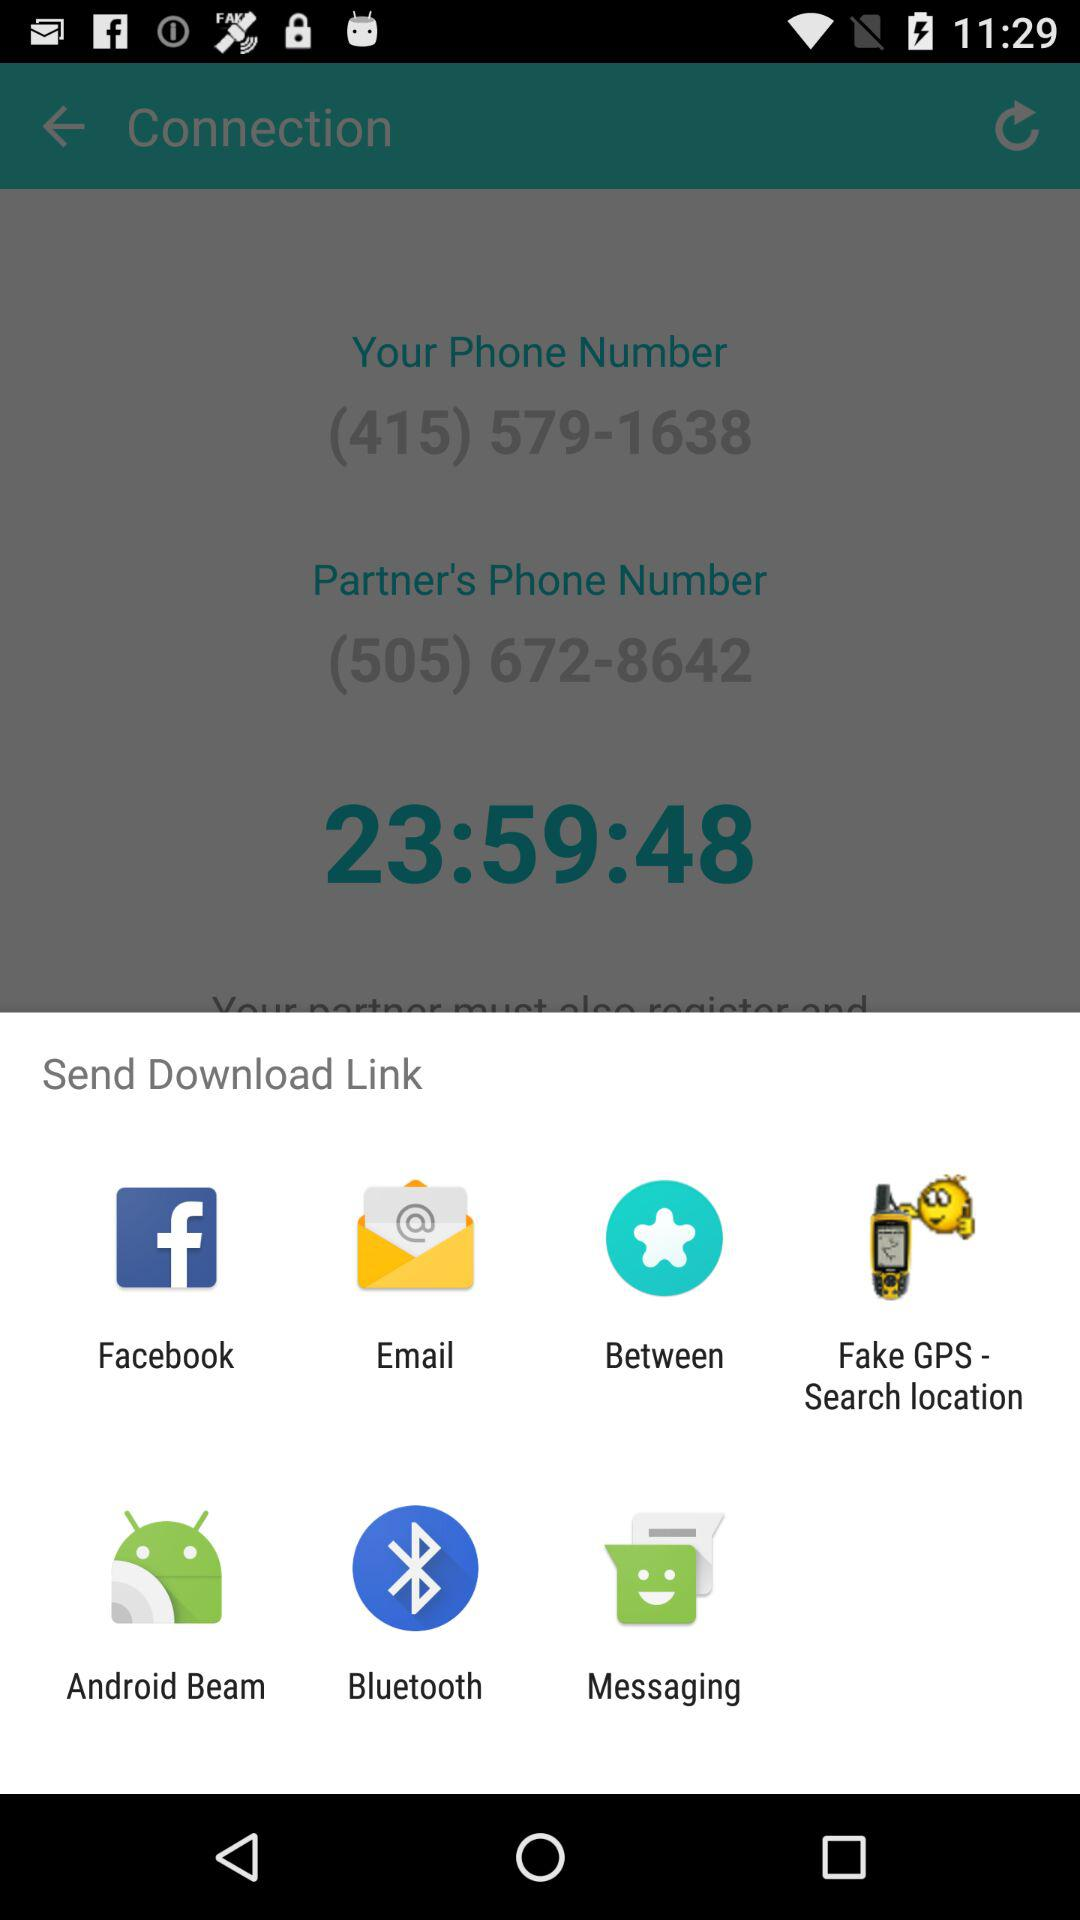Which are the different options available for sending the download link? The different options available for sending the download link are "Facebook", "Email", "Between", "Fake GPS - Search location", "Android Beam", "Bluetooth" and "Messaging". 